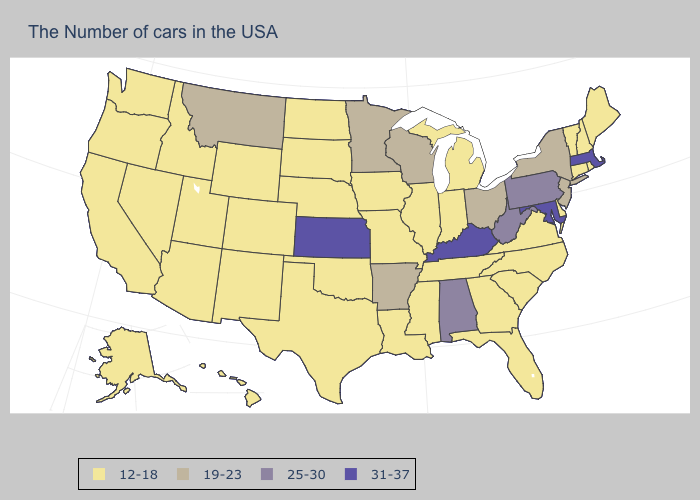Does the first symbol in the legend represent the smallest category?
Short answer required. Yes. Does Vermont have the same value as Nevada?
Short answer required. Yes. How many symbols are there in the legend?
Quick response, please. 4. Does the first symbol in the legend represent the smallest category?
Keep it brief. Yes. Does Michigan have the same value as Kentucky?
Concise answer only. No. Which states have the lowest value in the West?
Give a very brief answer. Wyoming, Colorado, New Mexico, Utah, Arizona, Idaho, Nevada, California, Washington, Oregon, Alaska, Hawaii. Name the states that have a value in the range 19-23?
Be succinct. New York, New Jersey, Ohio, Wisconsin, Arkansas, Minnesota, Montana. Does the map have missing data?
Quick response, please. No. Does the map have missing data?
Write a very short answer. No. Which states hav the highest value in the South?
Short answer required. Maryland, Kentucky. What is the value of Alaska?
Concise answer only. 12-18. Name the states that have a value in the range 19-23?
Quick response, please. New York, New Jersey, Ohio, Wisconsin, Arkansas, Minnesota, Montana. What is the lowest value in the USA?
Keep it brief. 12-18. 